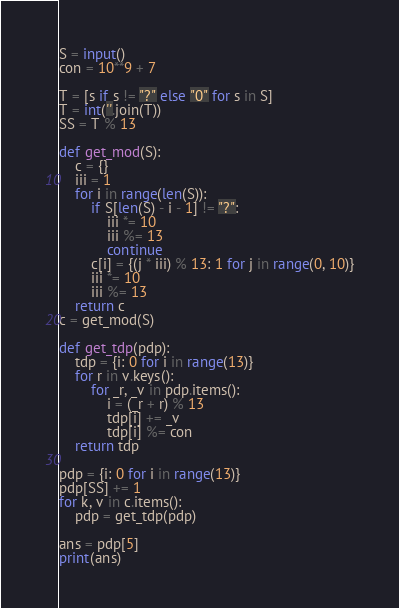<code> <loc_0><loc_0><loc_500><loc_500><_Python_>S = input()
con = 10**9 + 7

T = [s if s != "?" else "0" for s in S]
T = int(''.join(T))
SS = T % 13

def get_mod(S):
    c = {}
    iii = 1
    for i in range(len(S)):
        if S[len(S) - i - 1] != "?":
            iii *= 10
            iii %= 13
            continue
        c[i] = {(j * iii) % 13: 1 for j in range(0, 10)}
        iii *= 10
        iii %= 13
    return c
c = get_mod(S)

def get_tdp(pdp):
    tdp = {i: 0 for i in range(13)}
    for r in v.keys():
        for _r, _v in pdp.items():
            i = (_r + r) % 13
            tdp[i] += _v
            tdp[i] %= con
    return tdp

pdp = {i: 0 for i in range(13)}
pdp[SS] += 1
for k, v in c.items():
    pdp = get_tdp(pdp)

ans = pdp[5]
print(ans)</code> 